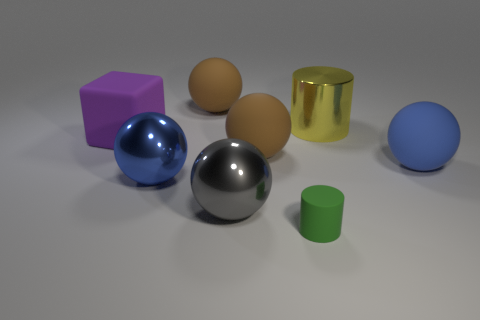Subtract all blue rubber spheres. How many spheres are left? 4 Add 2 small purple cubes. How many objects exist? 10 Subtract all green cylinders. How many cylinders are left? 1 Subtract all cubes. How many objects are left? 7 Subtract 3 balls. How many balls are left? 2 Subtract all purple cylinders. Subtract all purple blocks. How many cylinders are left? 2 Subtract all brown cylinders. How many gray balls are left? 1 Subtract all big yellow rubber balls. Subtract all small green rubber cylinders. How many objects are left? 7 Add 2 big gray metal objects. How many big gray metal objects are left? 3 Add 4 big brown balls. How many big brown balls exist? 6 